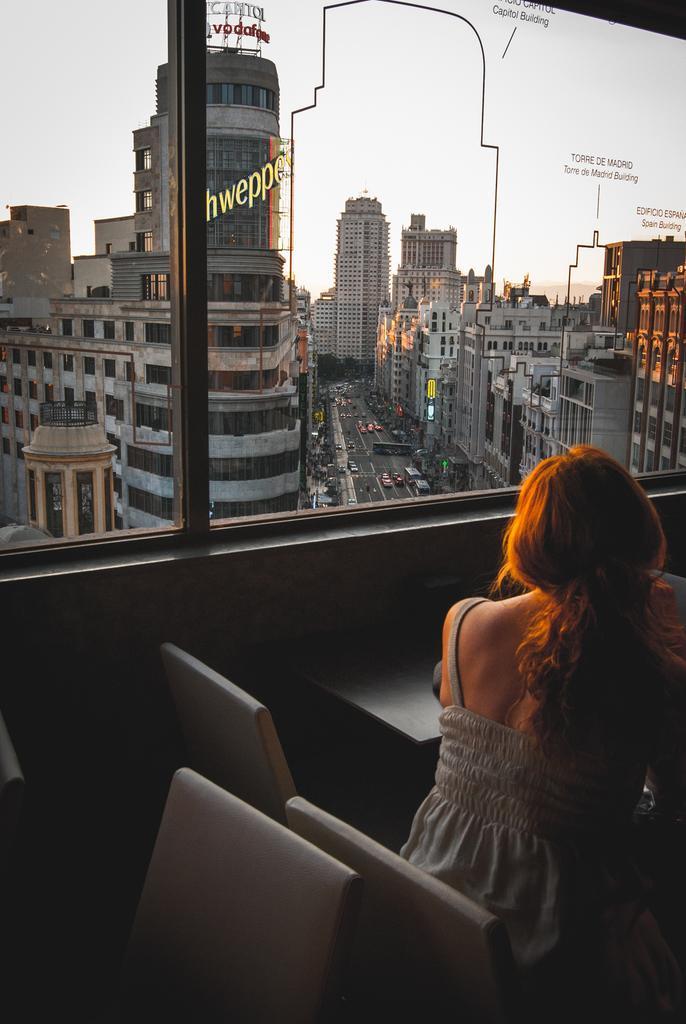Describe this image in one or two sentences. In this picture we can see a woman is sitting in a chair, there are some chairs and a table at the bottom, there is a glass in the middle, from the glass we can see buildings, there are some vehicles traveling on the road, there is some text on the glass, there is the sky at the top of the picture. 